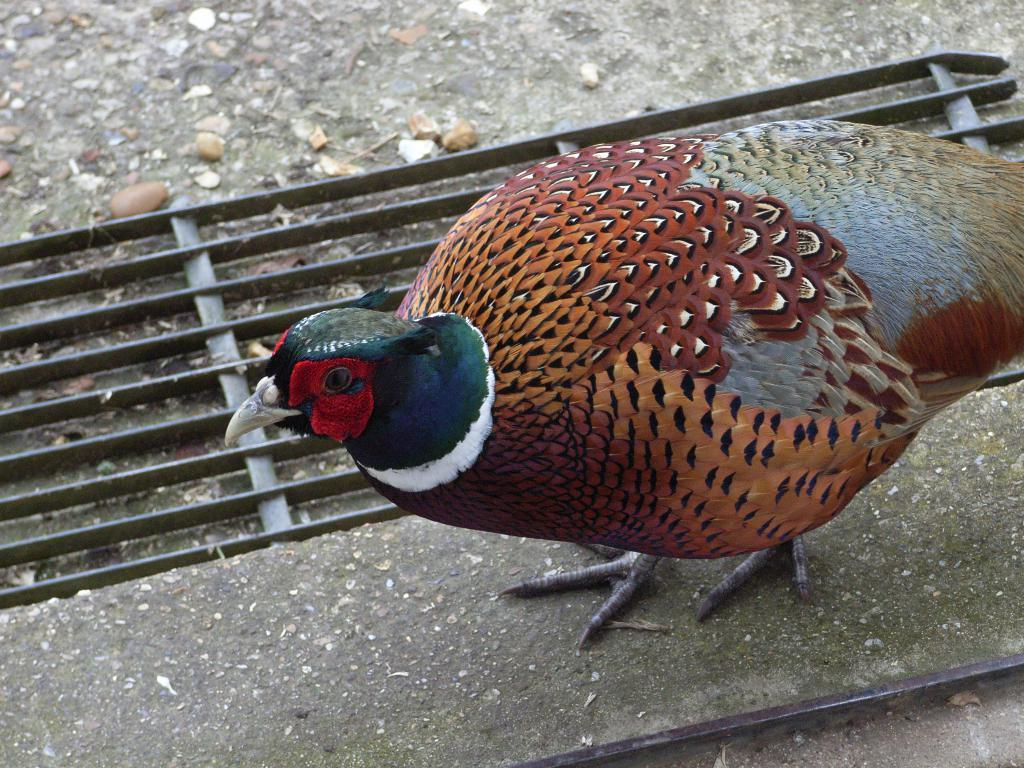What type of animal is on the surface in the image? There is a bird on the surface in the image. What material is the grill made of in the image? There is a metal grill in the image. What type of natural elements can be seen in the image? There are stones in the image. What type of joke is the bird telling on the metal grill in the image? There is no indication of a joke or any form of communication in the image; it simply shows a bird on a metal grill and stones. 